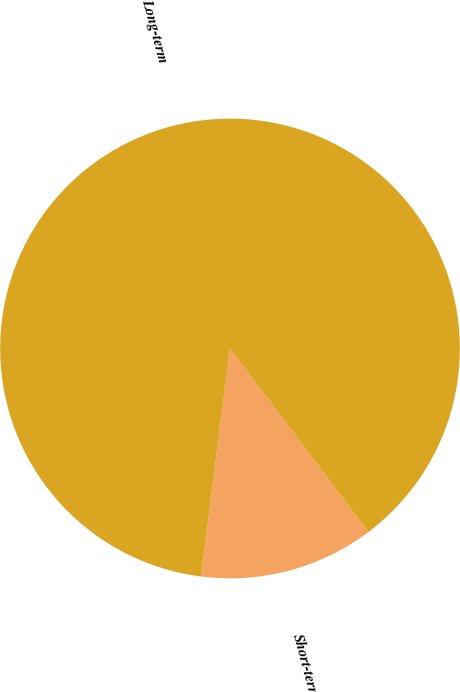<chart> <loc_0><loc_0><loc_500><loc_500><pie_chart><fcel>Short-term<fcel>Long-term<nl><fcel>12.29%<fcel>87.71%<nl></chart> 